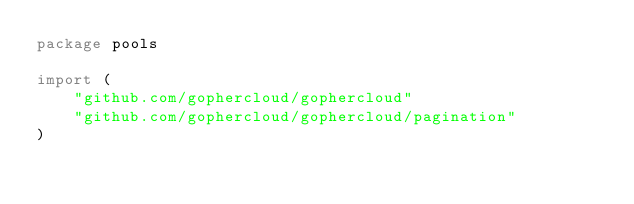Convert code to text. <code><loc_0><loc_0><loc_500><loc_500><_Go_>package pools

import (
	"github.com/gophercloud/gophercloud"
	"github.com/gophercloud/gophercloud/pagination"
)
</code> 